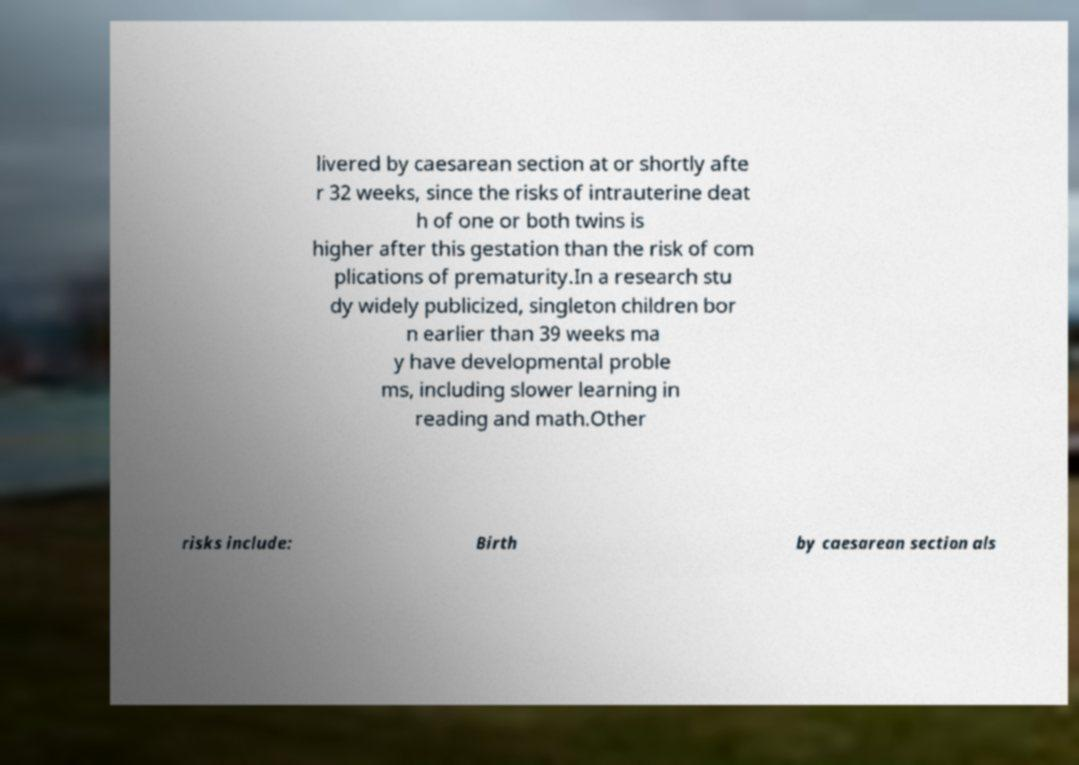Please identify and transcribe the text found in this image. livered by caesarean section at or shortly afte r 32 weeks, since the risks of intrauterine deat h of one or both twins is higher after this gestation than the risk of com plications of prematurity.In a research stu dy widely publicized, singleton children bor n earlier than 39 weeks ma y have developmental proble ms, including slower learning in reading and math.Other risks include: Birth by caesarean section als 